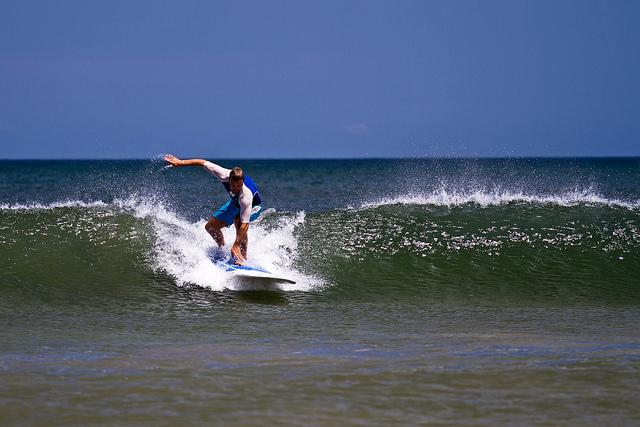Is the water calm?
Concise answer only. No. Are the man's arms down by his sides?
Quick response, please. No. What is the man doing?
Be succinct. Surfing. 